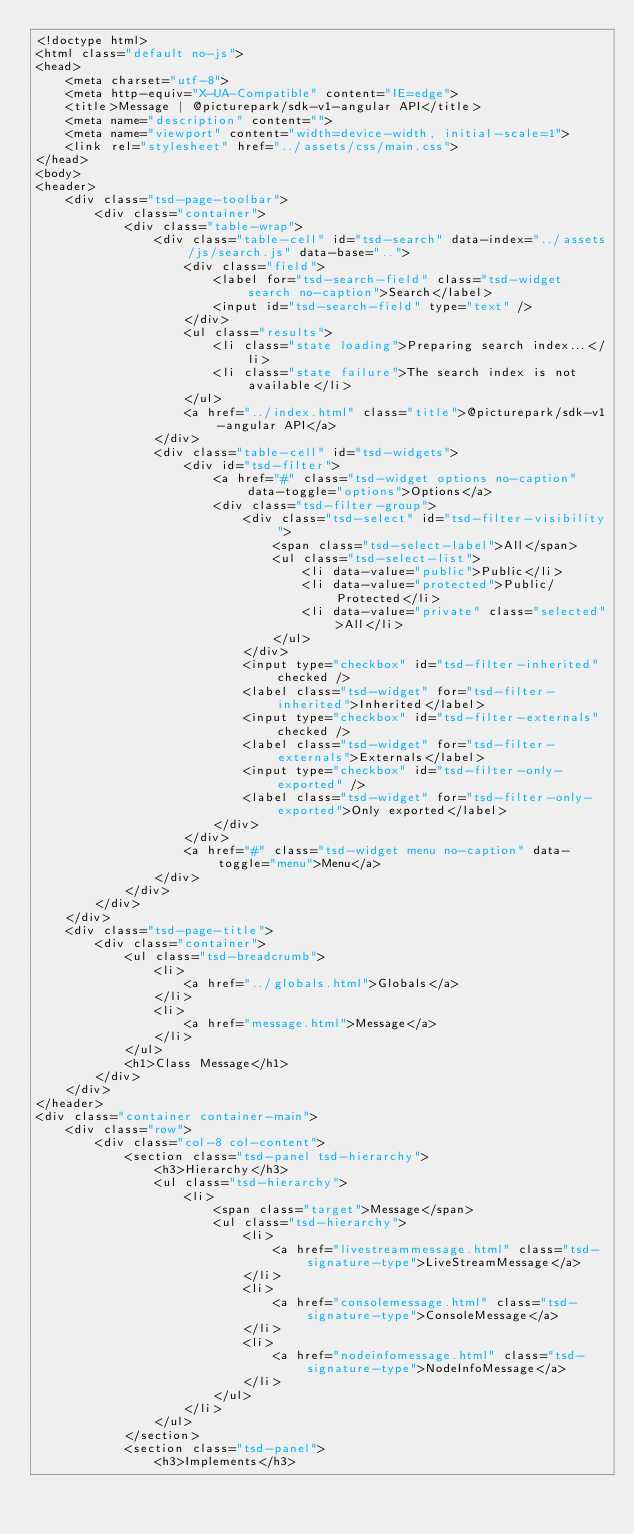Convert code to text. <code><loc_0><loc_0><loc_500><loc_500><_HTML_><!doctype html>
<html class="default no-js">
<head>
	<meta charset="utf-8">
	<meta http-equiv="X-UA-Compatible" content="IE=edge">
	<title>Message | @picturepark/sdk-v1-angular API</title>
	<meta name="description" content="">
	<meta name="viewport" content="width=device-width, initial-scale=1">
	<link rel="stylesheet" href="../assets/css/main.css">
</head>
<body>
<header>
	<div class="tsd-page-toolbar">
		<div class="container">
			<div class="table-wrap">
				<div class="table-cell" id="tsd-search" data-index="../assets/js/search.js" data-base="..">
					<div class="field">
						<label for="tsd-search-field" class="tsd-widget search no-caption">Search</label>
						<input id="tsd-search-field" type="text" />
					</div>
					<ul class="results">
						<li class="state loading">Preparing search index...</li>
						<li class="state failure">The search index is not available</li>
					</ul>
					<a href="../index.html" class="title">@picturepark/sdk-v1-angular API</a>
				</div>
				<div class="table-cell" id="tsd-widgets">
					<div id="tsd-filter">
						<a href="#" class="tsd-widget options no-caption" data-toggle="options">Options</a>
						<div class="tsd-filter-group">
							<div class="tsd-select" id="tsd-filter-visibility">
								<span class="tsd-select-label">All</span>
								<ul class="tsd-select-list">
									<li data-value="public">Public</li>
									<li data-value="protected">Public/Protected</li>
									<li data-value="private" class="selected">All</li>
								</ul>
							</div>
							<input type="checkbox" id="tsd-filter-inherited" checked />
							<label class="tsd-widget" for="tsd-filter-inherited">Inherited</label>
							<input type="checkbox" id="tsd-filter-externals" checked />
							<label class="tsd-widget" for="tsd-filter-externals">Externals</label>
							<input type="checkbox" id="tsd-filter-only-exported" />
							<label class="tsd-widget" for="tsd-filter-only-exported">Only exported</label>
						</div>
					</div>
					<a href="#" class="tsd-widget menu no-caption" data-toggle="menu">Menu</a>
				</div>
			</div>
		</div>
	</div>
	<div class="tsd-page-title">
		<div class="container">
			<ul class="tsd-breadcrumb">
				<li>
					<a href="../globals.html">Globals</a>
				</li>
				<li>
					<a href="message.html">Message</a>
				</li>
			</ul>
			<h1>Class Message</h1>
		</div>
	</div>
</header>
<div class="container container-main">
	<div class="row">
		<div class="col-8 col-content">
			<section class="tsd-panel tsd-hierarchy">
				<h3>Hierarchy</h3>
				<ul class="tsd-hierarchy">
					<li>
						<span class="target">Message</span>
						<ul class="tsd-hierarchy">
							<li>
								<a href="livestreammessage.html" class="tsd-signature-type">LiveStreamMessage</a>
							</li>
							<li>
								<a href="consolemessage.html" class="tsd-signature-type">ConsoleMessage</a>
							</li>
							<li>
								<a href="nodeinfomessage.html" class="tsd-signature-type">NodeInfoMessage</a>
							</li>
						</ul>
					</li>
				</ul>
			</section>
			<section class="tsd-panel">
				<h3>Implements</h3></code> 